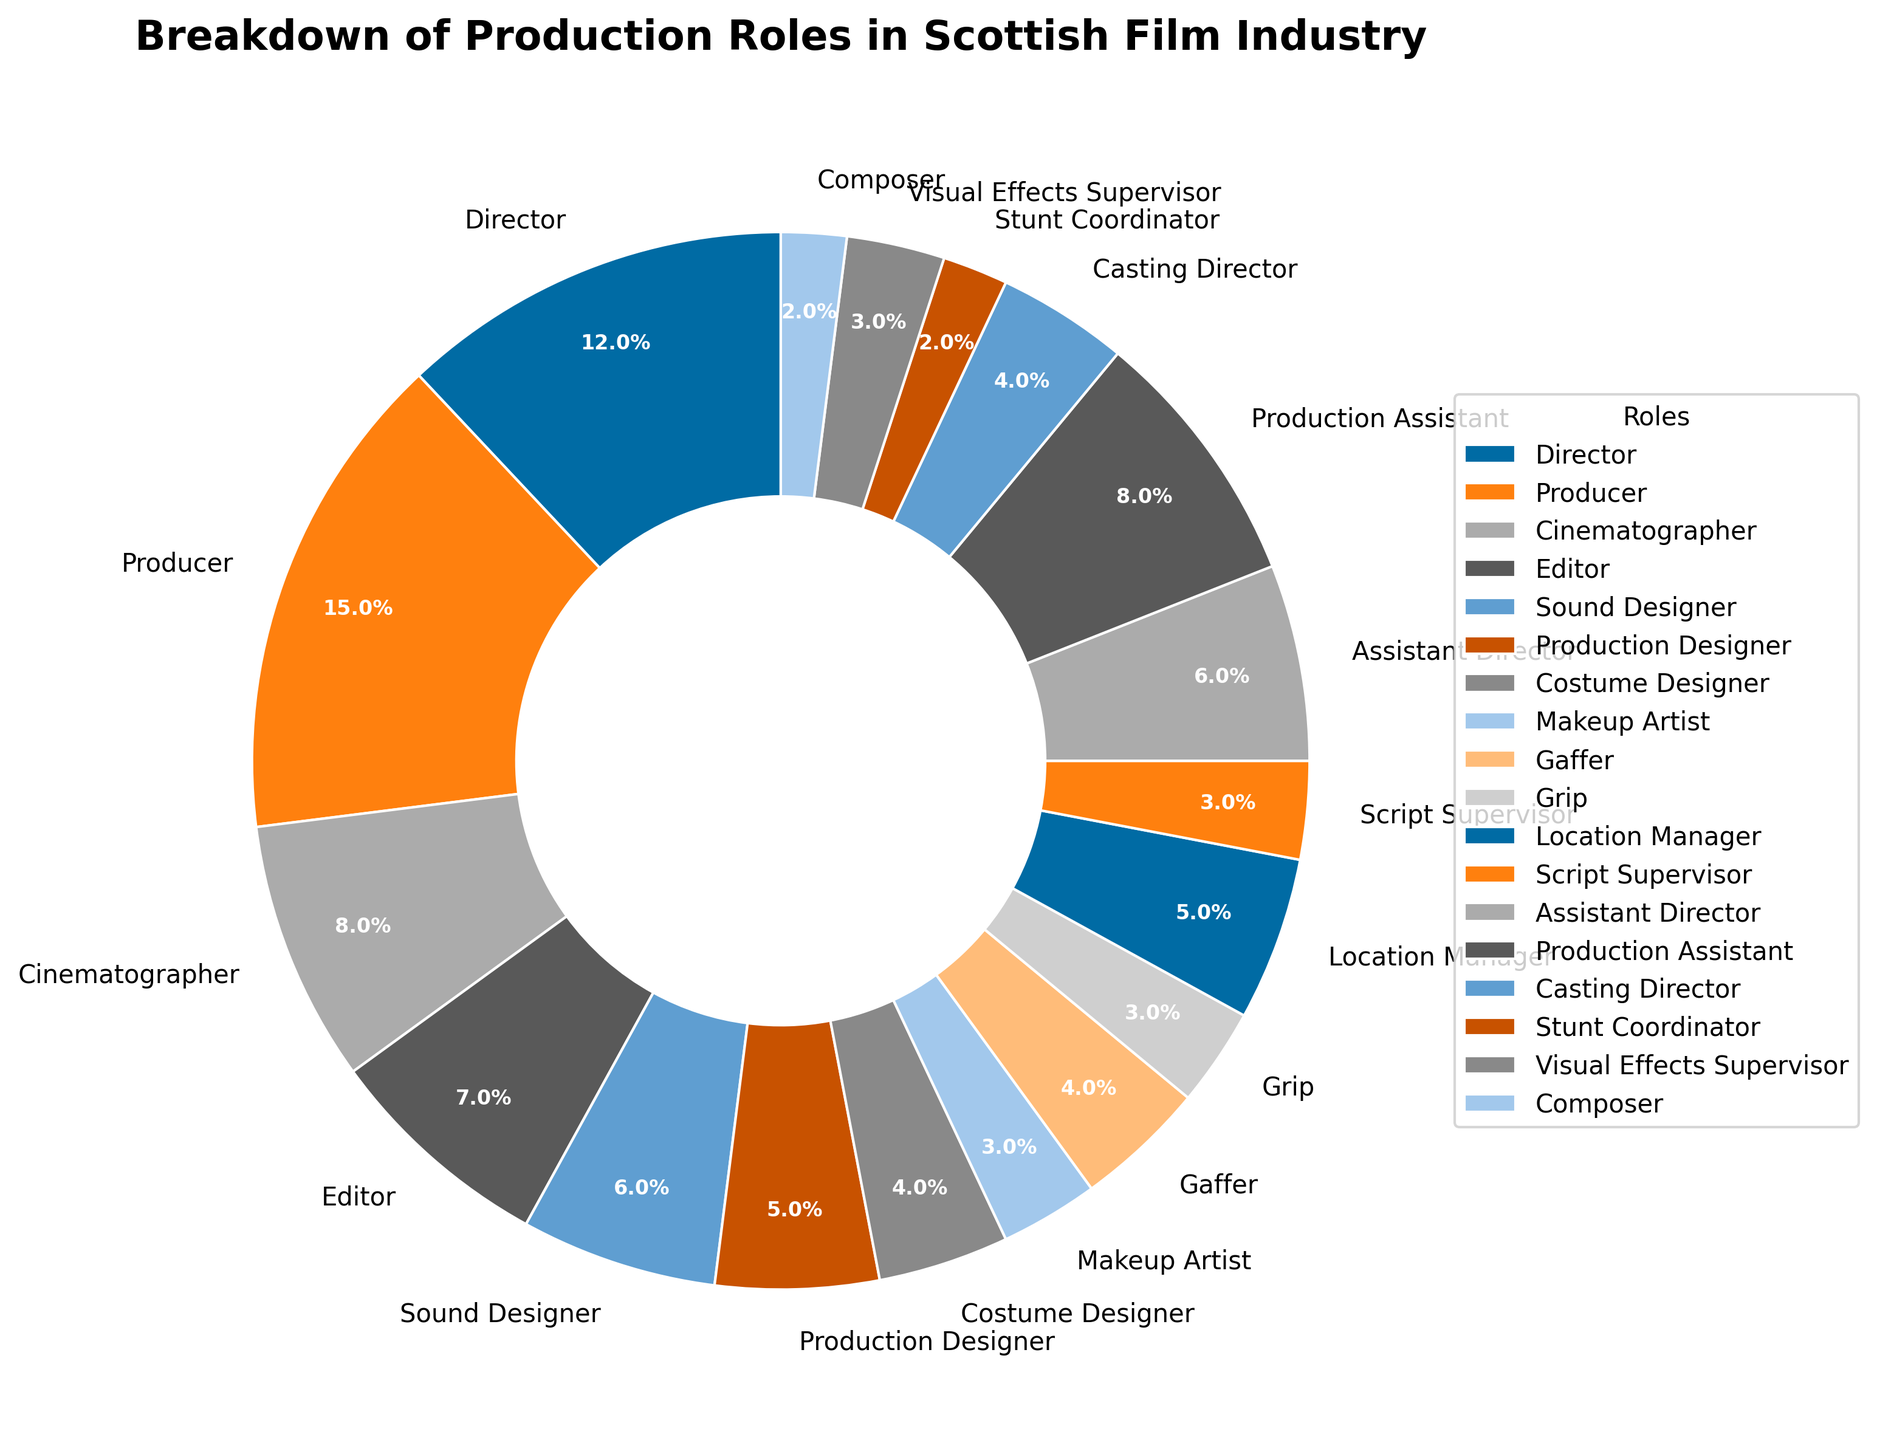Which role has the highest percentage in the chart? To identify the role with the highest percentage, examine the pie slices and their corresponding labels. The slice labeled "Producer" has the largest segment at 15%.
Answer: Producer What is the combined percentage of Cinematographer, Editor, and Sound Designer roles? Sum the percentages for the roles Cinematographer (8%), Editor (7%), and Sound Designer (6%). So, 8 + 7 + 6 = 21%.
Answer: 21% How does the percentage of Directors compare to Assistant Directors? Examine the pie chart to find the segments labeled "Director" (12%) and "Assistant Director" (6%). The percentage for Directors is twice that of Assistant Directors.
Answer: Director: 12%; Assistant Director: 6% What is the total percentage contribution of all roles with less than 5%? Identify all roles with percentages less than 5%: Costume Designer (4%), Makeup Artist (3%), Grip (3%), Script Supervisor (3%), Casting Director (4%), Visual Effects Supervisor (3%), Stunt Coordinator (2%), Composer (2%). Sum these values: 4 + 3 + 3 + 3 + 4 + 3 + 2 + 2 = 24%.
Answer: 24% Which two roles have an equal percentage, and what is that percentage? Find the roles that have identical segments. Costume Designer and Casting Director both have segments of 4%.
Answer: Costume Designer and Casting Director, 4% What's the difference in percentage between the role of Production Designer and Production Assistant? Locate the percentages for Production Designer (5%) and Production Assistant (8%), then calculate the difference: 8 - 5 = 3%.
Answer: 3% If you were to combine the percentage of Directors and Producers, what fraction of the chart would that be? Sum the percentages for Director (12%) and Producer (15%), which equals 27%. Since the entire chart represents 100%, this would be 27/100 or simplifying, the fraction 27/100.
Answer: 27/100 What is the ratio of the percentage of Gaffers to that of Stunt Coordinators? Identify the percentages for Gaffers (4%) and Stunt Coordinators (2%). The ratio is 4 to 2, which simplifies to 2:1.
Answer: 2:1 Is the percentage for Production Assistants equal to the combined percentage of Makeup Artists and Script Supervisors? Sum the percentages for Makeup Artists (3%) and Script Supervisors (3%) which equals 6%. Compare this to the percentage for Production Assistants (8%) which is not equal.
Answer: No Which role contributes less to the pie chart: Composer or Grip? Compare the segments for Composer (2%) and Grip (3%). Composer has a smaller percentage than Grip.
Answer: Composer 